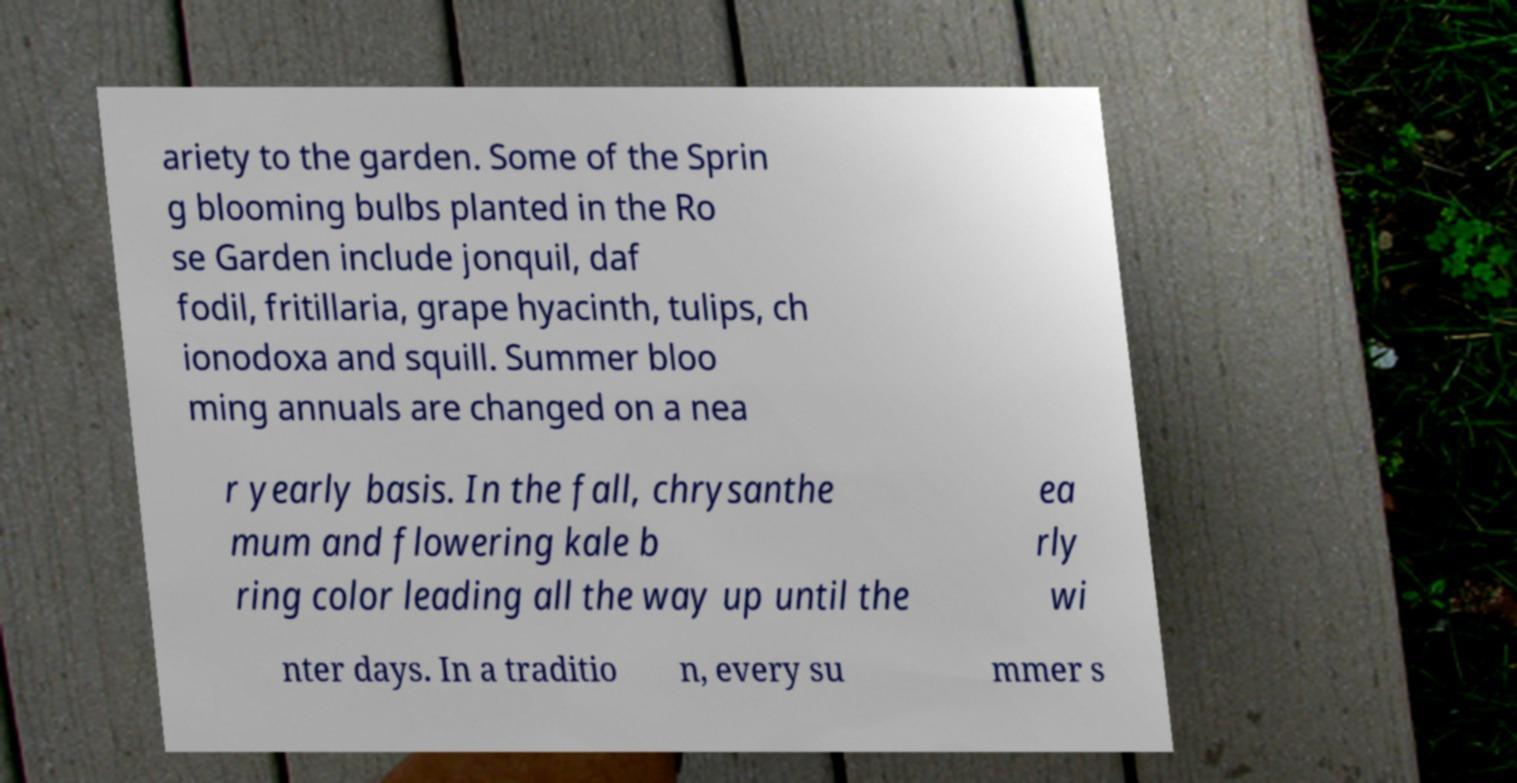Can you accurately transcribe the text from the provided image for me? ariety to the garden. Some of the Sprin g blooming bulbs planted in the Ro se Garden include jonquil, daf fodil, fritillaria, grape hyacinth, tulips, ch ionodoxa and squill. Summer bloo ming annuals are changed on a nea r yearly basis. In the fall, chrysanthe mum and flowering kale b ring color leading all the way up until the ea rly wi nter days. In a traditio n, every su mmer s 